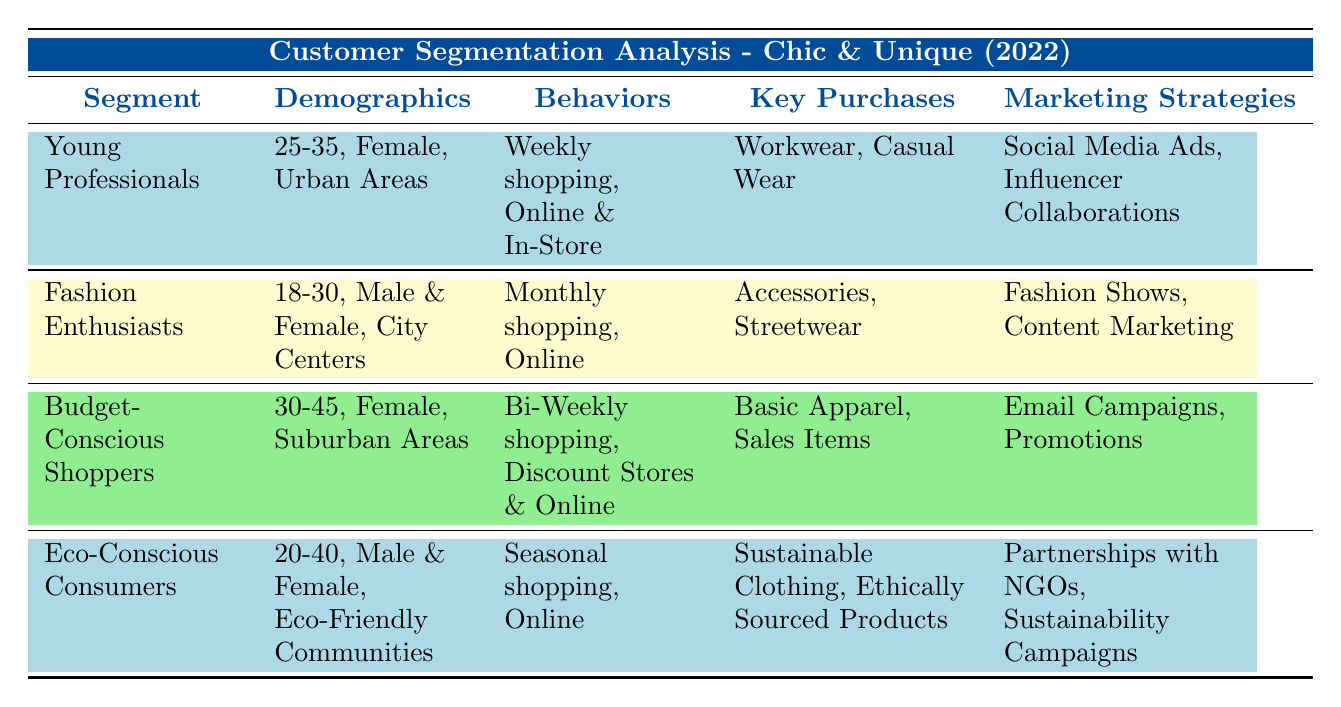What is the age range for the segment "Young Professionals"? The table specifies the demographics for this segment, which lists the age range as "25-35".
Answer: 25-35 Which segment has "Social Media Ads" as a marketing strategy? The "Young Professionals" segment has "Social Media Ads" listed under marketing strategies in the table.
Answer: Young Professionals What is the preferred shopping frequency for "Fashion Enthusiasts"? According to the table, the shopping frequency for this segment is "Monthly".
Answer: Monthly Are "Eco-Conscious Consumers" targeting urban areas? The demographics for "Eco-Conscious Consumers" indicate their location as "Eco-Friendly Communities," not urban areas, making the statement false.
Answer: No How many segments have "Online" as a preferred shopping channel? The table lists four segments, and the ones that include "Online" as a preferred shopping channel are "Young Professionals", "Fashion Enthusiasts", "Budget-Conscious Shoppers", and "Eco-Conscious Consumers". That's a total of 4 segments.
Answer: 4 What is the difference in shopping frequencies between "Budget-Conscious Shoppers" and "Young Professionals"? "Budget-Conscious Shoppers" have a shopping frequency of "Bi-Weekly", while "Young Professionals" shop "Weekly". This means Young Professionals shop more frequently by one frequency period.
Answer: One period Which segment is most likely to purchase "Workwear"? The "Young Professionals" segment lists "Workwear" as one of their key purchases in the table.
Answer: Young Professionals Do "Budget-Conscious Shoppers" prefer shopping online? The data specifies that "Budget-Conscious Shoppers" prefer "Discount Stores" and "Online", indicating that they do indeed prefer online shopping.
Answer: Yes What would be the combined age range of "Eco-Conscious Consumers" and "Fashion Enthusiasts"? The age range for "Eco-Conscious Consumers" is "20-40" and for "Fashion Enthusiasts" is "18-30". The combined age range covers from 18 to 40, encompassing both ranges entirely.
Answer: 18-40 